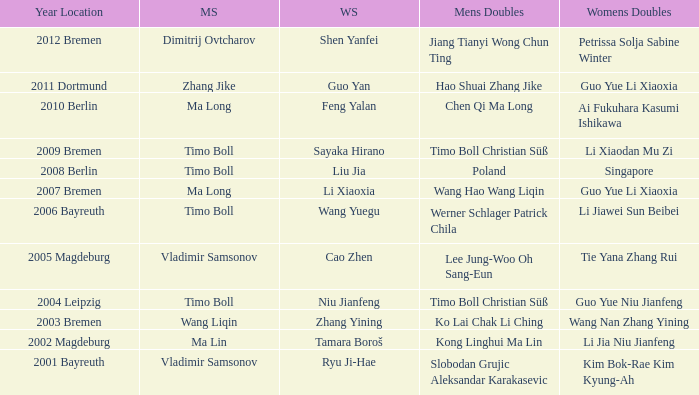Who won Womens Singles in the year that Ma Lin won Mens Singles? Tamara Boroš. 